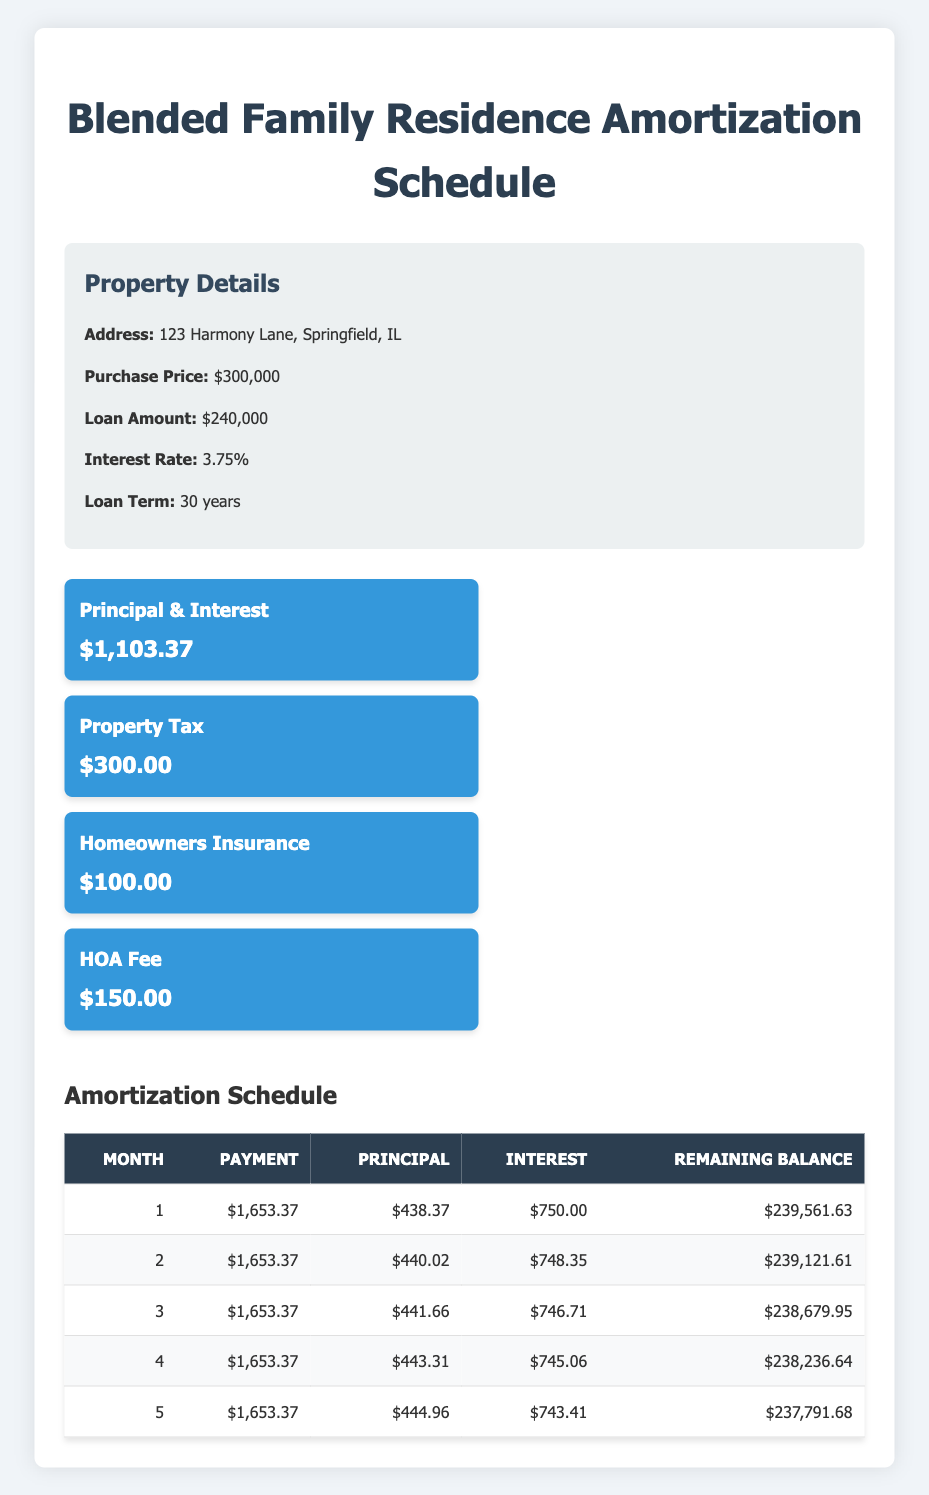What is the total monthly payment for the mortgage? The monthly payment can be found in the "total_monthly_payment" row of the monthly breakdown, which is listed as 1653.37.
Answer: 1653.37 How much is the principal portion of the first month's payment? The principal portion for the first month is located in the amortization schedule and is listed as 438.37.
Answer: 438.37 What is the remaining balance after the second month? The remaining balance after the second month can be found in the amortization schedule under the "remaining_balance" column for month 2, which is 239121.61.
Answer: 239121.61 Is the homeowner's insurance cost included in the total monthly payment? Homeowner's insurance is shown in the monthly breakdown and is included as a separate charge of 100.00, but it is part of the total monthly payment of 1653.37.
Answer: Yes What is the difference between the principal payment in the first month and the principal payment in the fifth month? To find this difference, locate the principal payments for month 1 (438.37) and month 5 (444.96), and subtract the two: 444.96 - 438.37 = 6.59.
Answer: 6.59 What is the average amount of interest paid in the first five months? Total interest paid in the first five months is the sum of individual interest payments (750.00 + 748.35 + 746.71 + 745.06 + 743.41 = 3733.53), and then divide by 5 to get the average: 3733.53 / 5 = 746.706. The average amount of interest paid is approximately 746.71.
Answer: 746.71 How much total principal is paid off in the first five months? The total principal paid in the first five months can be calculated by summing all principal payments: (438.37 + 440.02 + 441.66 + 443.31 + 444.96 = 2198.32).
Answer: 2198.32 Is the HOA fee part of the mortgage payment? The HOA fee of 150.00 is listed in the monthly breakdown and is included in the calculation of the total monthly payment of 1653.37.
Answer: Yes What is the total amount paid towards interest in the first three months? The total interest paid can be found by adding the interest amounts for the first three months: (750.00 + 748.35 + 746.71 = 2245.06).
Answer: 2245.06 